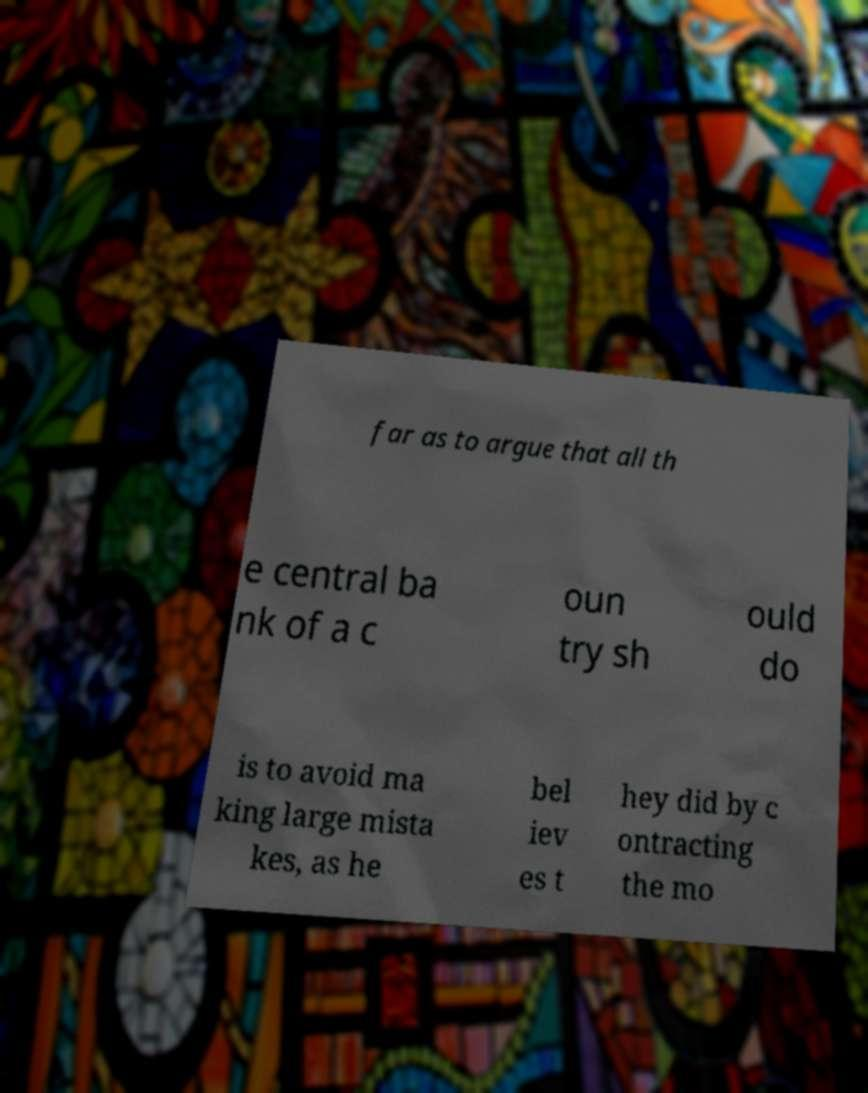Please identify and transcribe the text found in this image. far as to argue that all th e central ba nk of a c oun try sh ould do is to avoid ma king large mista kes, as he bel iev es t hey did by c ontracting the mo 